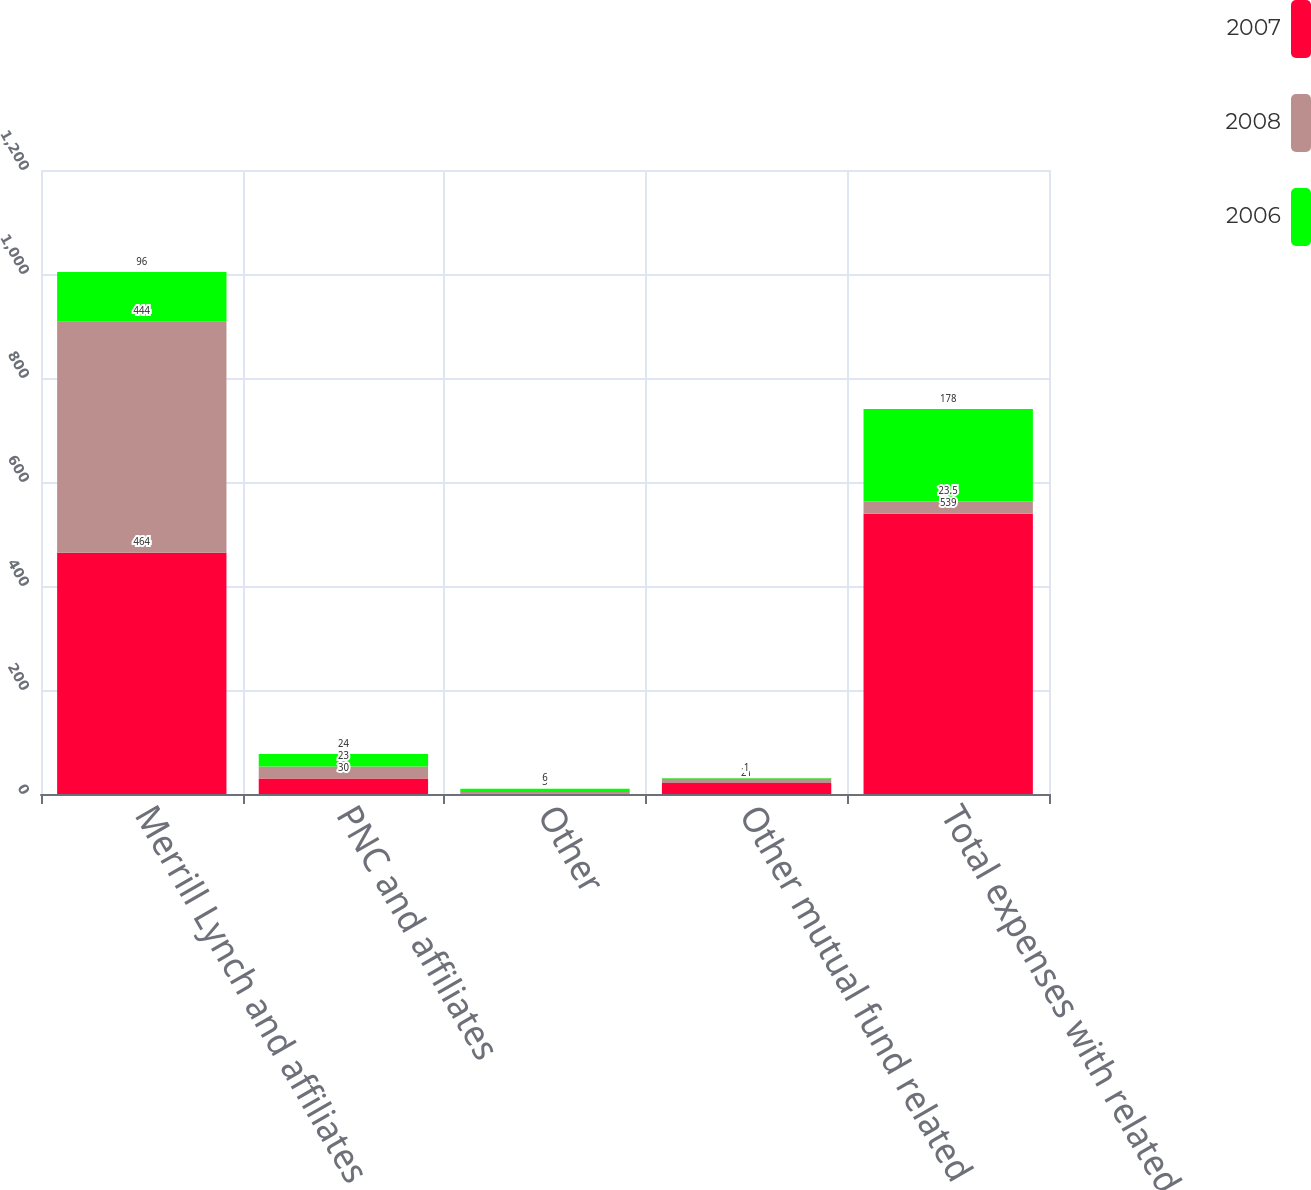<chart> <loc_0><loc_0><loc_500><loc_500><stacked_bar_chart><ecel><fcel>Merrill Lynch and affiliates<fcel>PNC and affiliates<fcel>Other<fcel>Other mutual fund related<fcel>Total expenses with related<nl><fcel>2007<fcel>464<fcel>30<fcel>1<fcel>21<fcel>539<nl><fcel>2008<fcel>444<fcel>23<fcel>3<fcel>9<fcel>23.5<nl><fcel>2006<fcel>96<fcel>24<fcel>6<fcel>1<fcel>178<nl></chart> 